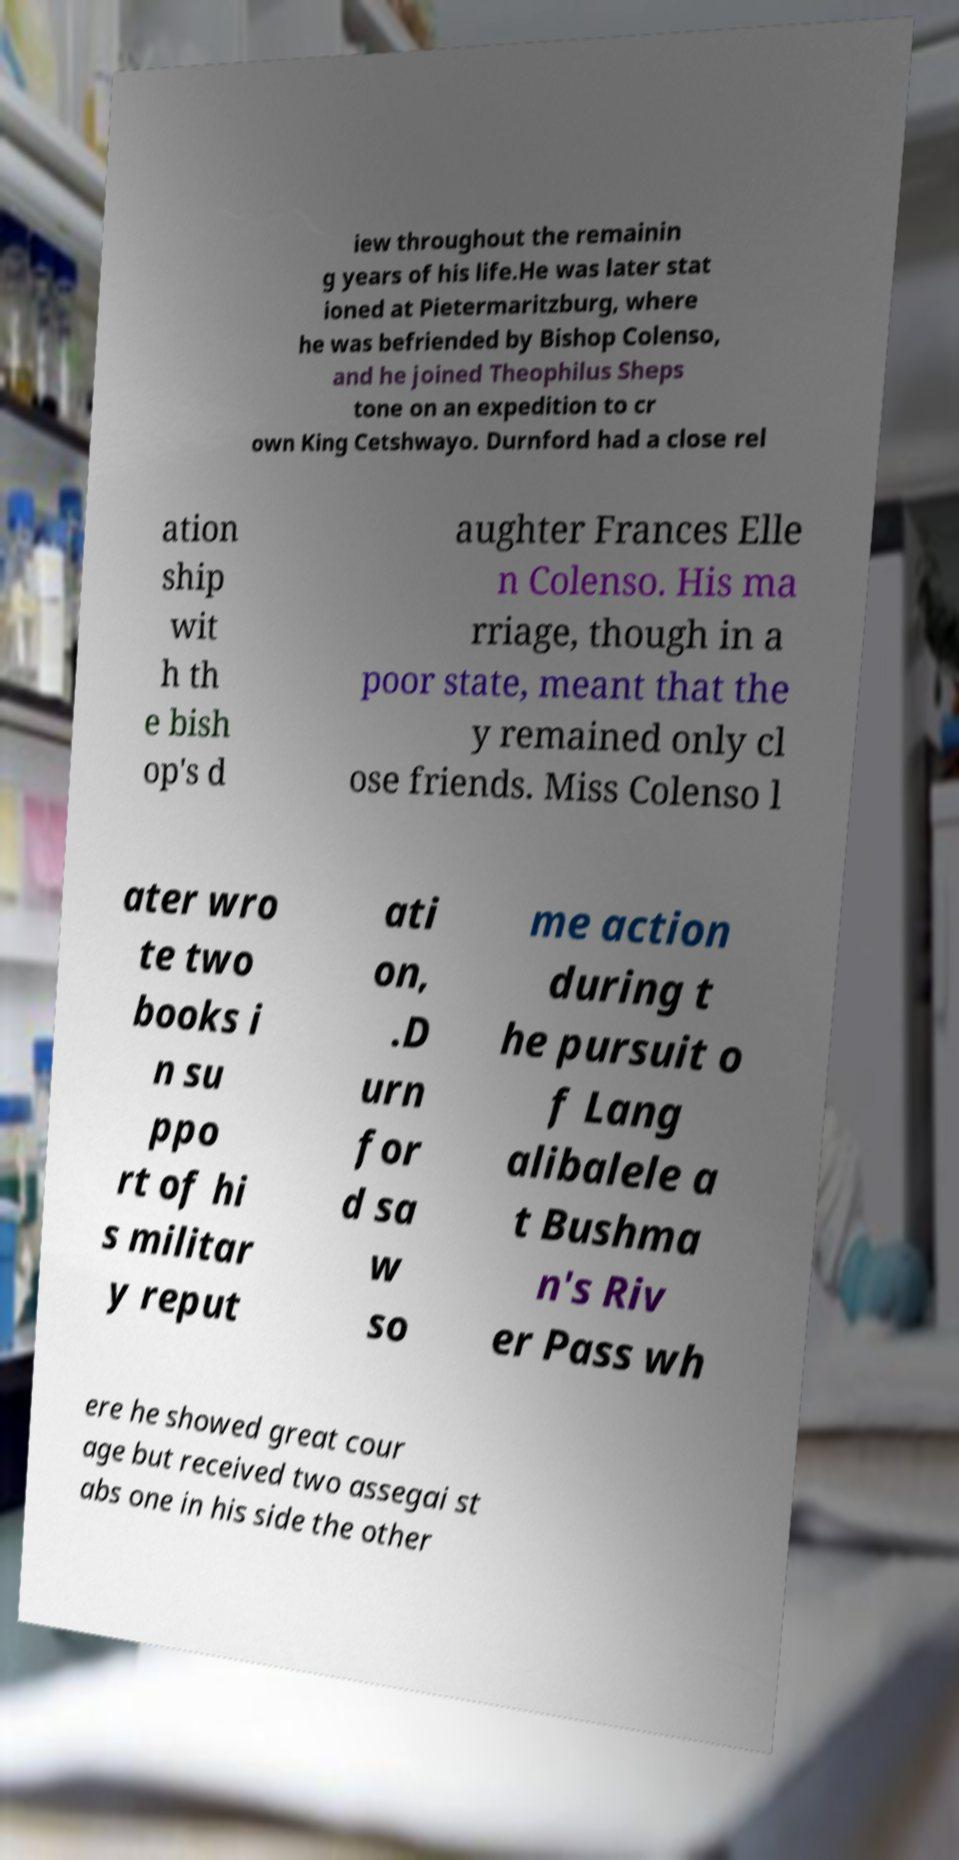Can you accurately transcribe the text from the provided image for me? iew throughout the remainin g years of his life.He was later stat ioned at Pietermaritzburg, where he was befriended by Bishop Colenso, and he joined Theophilus Sheps tone on an expedition to cr own King Cetshwayo. Durnford had a close rel ation ship wit h th e bish op's d aughter Frances Elle n Colenso. His ma rriage, though in a poor state, meant that the y remained only cl ose friends. Miss Colenso l ater wro te two books i n su ppo rt of hi s militar y reput ati on, .D urn for d sa w so me action during t he pursuit o f Lang alibalele a t Bushma n's Riv er Pass wh ere he showed great cour age but received two assegai st abs one in his side the other 